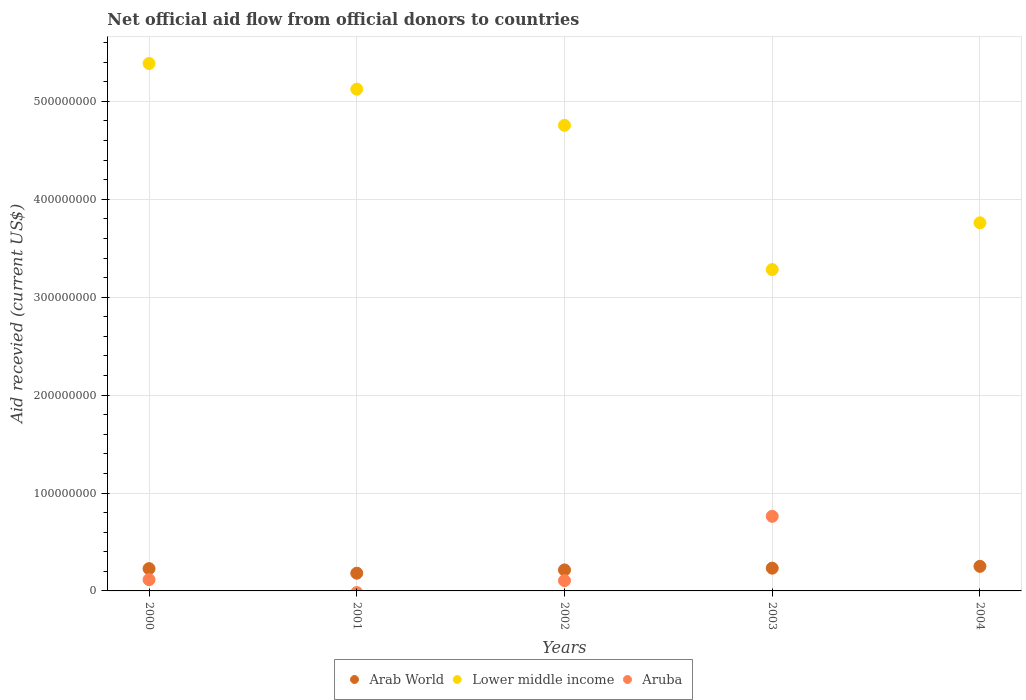How many different coloured dotlines are there?
Keep it short and to the point. 3. Is the number of dotlines equal to the number of legend labels?
Your response must be concise. No. What is the total aid received in Aruba in 2000?
Your answer should be compact. 1.15e+07. Across all years, what is the maximum total aid received in Aruba?
Provide a short and direct response. 7.62e+07. Across all years, what is the minimum total aid received in Lower middle income?
Keep it short and to the point. 3.28e+08. In which year was the total aid received in Lower middle income maximum?
Your response must be concise. 2000. What is the total total aid received in Arab World in the graph?
Offer a very short reply. 1.11e+08. What is the difference between the total aid received in Lower middle income in 2000 and that in 2003?
Ensure brevity in your answer.  2.10e+08. What is the difference between the total aid received in Arab World in 2002 and the total aid received in Aruba in 2000?
Your answer should be very brief. 9.94e+06. What is the average total aid received in Arab World per year?
Make the answer very short. 2.21e+07. In the year 2001, what is the difference between the total aid received in Arab World and total aid received in Lower middle income?
Make the answer very short. -4.94e+08. In how many years, is the total aid received in Lower middle income greater than 40000000 US$?
Your response must be concise. 5. What is the ratio of the total aid received in Lower middle income in 2000 to that in 2004?
Make the answer very short. 1.43. Is the total aid received in Lower middle income in 2001 less than that in 2004?
Provide a succinct answer. No. Is the difference between the total aid received in Arab World in 2000 and 2001 greater than the difference between the total aid received in Lower middle income in 2000 and 2001?
Give a very brief answer. No. What is the difference between the highest and the second highest total aid received in Arab World?
Provide a short and direct response. 1.86e+06. In how many years, is the total aid received in Aruba greater than the average total aid received in Aruba taken over all years?
Your answer should be very brief. 1. Is the sum of the total aid received in Lower middle income in 2000 and 2004 greater than the maximum total aid received in Aruba across all years?
Your answer should be compact. Yes. Is it the case that in every year, the sum of the total aid received in Lower middle income and total aid received in Arab World  is greater than the total aid received in Aruba?
Your answer should be very brief. Yes. Is the total aid received in Aruba strictly greater than the total aid received in Lower middle income over the years?
Provide a short and direct response. No. How many dotlines are there?
Keep it short and to the point. 3. What is the difference between two consecutive major ticks on the Y-axis?
Provide a succinct answer. 1.00e+08. Where does the legend appear in the graph?
Give a very brief answer. Bottom center. How many legend labels are there?
Ensure brevity in your answer.  3. How are the legend labels stacked?
Your answer should be compact. Horizontal. What is the title of the graph?
Make the answer very short. Net official aid flow from official donors to countries. Does "Brunei Darussalam" appear as one of the legend labels in the graph?
Make the answer very short. No. What is the label or title of the X-axis?
Give a very brief answer. Years. What is the label or title of the Y-axis?
Your answer should be very brief. Aid recevied (current US$). What is the Aid recevied (current US$) in Arab World in 2000?
Your answer should be compact. 2.28e+07. What is the Aid recevied (current US$) of Lower middle income in 2000?
Your answer should be compact. 5.39e+08. What is the Aid recevied (current US$) of Aruba in 2000?
Your response must be concise. 1.15e+07. What is the Aid recevied (current US$) in Arab World in 2001?
Offer a very short reply. 1.81e+07. What is the Aid recevied (current US$) of Lower middle income in 2001?
Keep it short and to the point. 5.12e+08. What is the Aid recevied (current US$) of Arab World in 2002?
Your response must be concise. 2.14e+07. What is the Aid recevied (current US$) in Lower middle income in 2002?
Your answer should be compact. 4.76e+08. What is the Aid recevied (current US$) of Aruba in 2002?
Offer a terse response. 1.05e+07. What is the Aid recevied (current US$) of Arab World in 2003?
Your answer should be compact. 2.32e+07. What is the Aid recevied (current US$) of Lower middle income in 2003?
Keep it short and to the point. 3.28e+08. What is the Aid recevied (current US$) of Aruba in 2003?
Make the answer very short. 7.62e+07. What is the Aid recevied (current US$) of Arab World in 2004?
Provide a succinct answer. 2.51e+07. What is the Aid recevied (current US$) of Lower middle income in 2004?
Provide a short and direct response. 3.76e+08. Across all years, what is the maximum Aid recevied (current US$) in Arab World?
Your response must be concise. 2.51e+07. Across all years, what is the maximum Aid recevied (current US$) in Lower middle income?
Your answer should be very brief. 5.39e+08. Across all years, what is the maximum Aid recevied (current US$) in Aruba?
Ensure brevity in your answer.  7.62e+07. Across all years, what is the minimum Aid recevied (current US$) of Arab World?
Offer a very short reply. 1.81e+07. Across all years, what is the minimum Aid recevied (current US$) of Lower middle income?
Your response must be concise. 3.28e+08. Across all years, what is the minimum Aid recevied (current US$) of Aruba?
Provide a short and direct response. 0. What is the total Aid recevied (current US$) in Arab World in the graph?
Give a very brief answer. 1.11e+08. What is the total Aid recevied (current US$) of Lower middle income in the graph?
Give a very brief answer. 2.23e+09. What is the total Aid recevied (current US$) in Aruba in the graph?
Your response must be concise. 9.82e+07. What is the difference between the Aid recevied (current US$) in Arab World in 2000 and that in 2001?
Ensure brevity in your answer.  4.67e+06. What is the difference between the Aid recevied (current US$) of Lower middle income in 2000 and that in 2001?
Offer a very short reply. 2.62e+07. What is the difference between the Aid recevied (current US$) in Arab World in 2000 and that in 2002?
Ensure brevity in your answer.  1.34e+06. What is the difference between the Aid recevied (current US$) in Lower middle income in 2000 and that in 2002?
Your answer should be very brief. 6.32e+07. What is the difference between the Aid recevied (current US$) in Aruba in 2000 and that in 2002?
Ensure brevity in your answer.  1.01e+06. What is the difference between the Aid recevied (current US$) in Arab World in 2000 and that in 2003?
Provide a short and direct response. -4.70e+05. What is the difference between the Aid recevied (current US$) of Lower middle income in 2000 and that in 2003?
Keep it short and to the point. 2.10e+08. What is the difference between the Aid recevied (current US$) in Aruba in 2000 and that in 2003?
Ensure brevity in your answer.  -6.47e+07. What is the difference between the Aid recevied (current US$) in Arab World in 2000 and that in 2004?
Your response must be concise. -2.33e+06. What is the difference between the Aid recevied (current US$) in Lower middle income in 2000 and that in 2004?
Make the answer very short. 1.63e+08. What is the difference between the Aid recevied (current US$) of Arab World in 2001 and that in 2002?
Your response must be concise. -3.33e+06. What is the difference between the Aid recevied (current US$) in Lower middle income in 2001 and that in 2002?
Give a very brief answer. 3.69e+07. What is the difference between the Aid recevied (current US$) in Arab World in 2001 and that in 2003?
Give a very brief answer. -5.14e+06. What is the difference between the Aid recevied (current US$) in Lower middle income in 2001 and that in 2003?
Offer a terse response. 1.84e+08. What is the difference between the Aid recevied (current US$) in Arab World in 2001 and that in 2004?
Your answer should be very brief. -7.00e+06. What is the difference between the Aid recevied (current US$) of Lower middle income in 2001 and that in 2004?
Provide a short and direct response. 1.36e+08. What is the difference between the Aid recevied (current US$) of Arab World in 2002 and that in 2003?
Give a very brief answer. -1.81e+06. What is the difference between the Aid recevied (current US$) of Lower middle income in 2002 and that in 2003?
Make the answer very short. 1.47e+08. What is the difference between the Aid recevied (current US$) in Aruba in 2002 and that in 2003?
Make the answer very short. -6.57e+07. What is the difference between the Aid recevied (current US$) of Arab World in 2002 and that in 2004?
Provide a succinct answer. -3.67e+06. What is the difference between the Aid recevied (current US$) of Lower middle income in 2002 and that in 2004?
Your answer should be compact. 9.96e+07. What is the difference between the Aid recevied (current US$) of Arab World in 2003 and that in 2004?
Give a very brief answer. -1.86e+06. What is the difference between the Aid recevied (current US$) in Lower middle income in 2003 and that in 2004?
Offer a terse response. -4.78e+07. What is the difference between the Aid recevied (current US$) in Arab World in 2000 and the Aid recevied (current US$) in Lower middle income in 2001?
Keep it short and to the point. -4.90e+08. What is the difference between the Aid recevied (current US$) in Arab World in 2000 and the Aid recevied (current US$) in Lower middle income in 2002?
Your answer should be very brief. -4.53e+08. What is the difference between the Aid recevied (current US$) of Arab World in 2000 and the Aid recevied (current US$) of Aruba in 2002?
Provide a short and direct response. 1.23e+07. What is the difference between the Aid recevied (current US$) of Lower middle income in 2000 and the Aid recevied (current US$) of Aruba in 2002?
Provide a succinct answer. 5.28e+08. What is the difference between the Aid recevied (current US$) in Arab World in 2000 and the Aid recevied (current US$) in Lower middle income in 2003?
Your answer should be very brief. -3.05e+08. What is the difference between the Aid recevied (current US$) of Arab World in 2000 and the Aid recevied (current US$) of Aruba in 2003?
Your response must be concise. -5.34e+07. What is the difference between the Aid recevied (current US$) of Lower middle income in 2000 and the Aid recevied (current US$) of Aruba in 2003?
Ensure brevity in your answer.  4.62e+08. What is the difference between the Aid recevied (current US$) in Arab World in 2000 and the Aid recevied (current US$) in Lower middle income in 2004?
Your answer should be very brief. -3.53e+08. What is the difference between the Aid recevied (current US$) in Arab World in 2001 and the Aid recevied (current US$) in Lower middle income in 2002?
Offer a very short reply. -4.57e+08. What is the difference between the Aid recevied (current US$) of Arab World in 2001 and the Aid recevied (current US$) of Aruba in 2002?
Provide a short and direct response. 7.62e+06. What is the difference between the Aid recevied (current US$) of Lower middle income in 2001 and the Aid recevied (current US$) of Aruba in 2002?
Keep it short and to the point. 5.02e+08. What is the difference between the Aid recevied (current US$) in Arab World in 2001 and the Aid recevied (current US$) in Lower middle income in 2003?
Your response must be concise. -3.10e+08. What is the difference between the Aid recevied (current US$) in Arab World in 2001 and the Aid recevied (current US$) in Aruba in 2003?
Provide a succinct answer. -5.81e+07. What is the difference between the Aid recevied (current US$) in Lower middle income in 2001 and the Aid recevied (current US$) in Aruba in 2003?
Your answer should be very brief. 4.36e+08. What is the difference between the Aid recevied (current US$) of Arab World in 2001 and the Aid recevied (current US$) of Lower middle income in 2004?
Your response must be concise. -3.58e+08. What is the difference between the Aid recevied (current US$) in Arab World in 2002 and the Aid recevied (current US$) in Lower middle income in 2003?
Offer a very short reply. -3.07e+08. What is the difference between the Aid recevied (current US$) of Arab World in 2002 and the Aid recevied (current US$) of Aruba in 2003?
Keep it short and to the point. -5.48e+07. What is the difference between the Aid recevied (current US$) in Lower middle income in 2002 and the Aid recevied (current US$) in Aruba in 2003?
Offer a very short reply. 3.99e+08. What is the difference between the Aid recevied (current US$) in Arab World in 2002 and the Aid recevied (current US$) in Lower middle income in 2004?
Offer a terse response. -3.55e+08. What is the difference between the Aid recevied (current US$) in Arab World in 2003 and the Aid recevied (current US$) in Lower middle income in 2004?
Your answer should be very brief. -3.53e+08. What is the average Aid recevied (current US$) of Arab World per year?
Make the answer very short. 2.21e+07. What is the average Aid recevied (current US$) in Lower middle income per year?
Keep it short and to the point. 4.46e+08. What is the average Aid recevied (current US$) of Aruba per year?
Provide a short and direct response. 1.96e+07. In the year 2000, what is the difference between the Aid recevied (current US$) in Arab World and Aid recevied (current US$) in Lower middle income?
Your answer should be very brief. -5.16e+08. In the year 2000, what is the difference between the Aid recevied (current US$) in Arab World and Aid recevied (current US$) in Aruba?
Your response must be concise. 1.13e+07. In the year 2000, what is the difference between the Aid recevied (current US$) of Lower middle income and Aid recevied (current US$) of Aruba?
Provide a short and direct response. 5.27e+08. In the year 2001, what is the difference between the Aid recevied (current US$) in Arab World and Aid recevied (current US$) in Lower middle income?
Your answer should be compact. -4.94e+08. In the year 2002, what is the difference between the Aid recevied (current US$) of Arab World and Aid recevied (current US$) of Lower middle income?
Offer a terse response. -4.54e+08. In the year 2002, what is the difference between the Aid recevied (current US$) in Arab World and Aid recevied (current US$) in Aruba?
Offer a very short reply. 1.10e+07. In the year 2002, what is the difference between the Aid recevied (current US$) in Lower middle income and Aid recevied (current US$) in Aruba?
Provide a succinct answer. 4.65e+08. In the year 2003, what is the difference between the Aid recevied (current US$) in Arab World and Aid recevied (current US$) in Lower middle income?
Make the answer very short. -3.05e+08. In the year 2003, what is the difference between the Aid recevied (current US$) of Arab World and Aid recevied (current US$) of Aruba?
Your answer should be compact. -5.30e+07. In the year 2003, what is the difference between the Aid recevied (current US$) in Lower middle income and Aid recevied (current US$) in Aruba?
Ensure brevity in your answer.  2.52e+08. In the year 2004, what is the difference between the Aid recevied (current US$) in Arab World and Aid recevied (current US$) in Lower middle income?
Your answer should be very brief. -3.51e+08. What is the ratio of the Aid recevied (current US$) in Arab World in 2000 to that in 2001?
Your answer should be very brief. 1.26. What is the ratio of the Aid recevied (current US$) in Lower middle income in 2000 to that in 2001?
Your answer should be very brief. 1.05. What is the ratio of the Aid recevied (current US$) of Arab World in 2000 to that in 2002?
Offer a terse response. 1.06. What is the ratio of the Aid recevied (current US$) in Lower middle income in 2000 to that in 2002?
Provide a short and direct response. 1.13. What is the ratio of the Aid recevied (current US$) in Aruba in 2000 to that in 2002?
Keep it short and to the point. 1.1. What is the ratio of the Aid recevied (current US$) in Arab World in 2000 to that in 2003?
Offer a very short reply. 0.98. What is the ratio of the Aid recevied (current US$) of Lower middle income in 2000 to that in 2003?
Provide a succinct answer. 1.64. What is the ratio of the Aid recevied (current US$) in Aruba in 2000 to that in 2003?
Provide a succinct answer. 0.15. What is the ratio of the Aid recevied (current US$) of Arab World in 2000 to that in 2004?
Keep it short and to the point. 0.91. What is the ratio of the Aid recevied (current US$) in Lower middle income in 2000 to that in 2004?
Your answer should be very brief. 1.43. What is the ratio of the Aid recevied (current US$) in Arab World in 2001 to that in 2002?
Your answer should be very brief. 0.84. What is the ratio of the Aid recevied (current US$) in Lower middle income in 2001 to that in 2002?
Provide a short and direct response. 1.08. What is the ratio of the Aid recevied (current US$) of Arab World in 2001 to that in 2003?
Your response must be concise. 0.78. What is the ratio of the Aid recevied (current US$) of Lower middle income in 2001 to that in 2003?
Offer a terse response. 1.56. What is the ratio of the Aid recevied (current US$) in Arab World in 2001 to that in 2004?
Your answer should be very brief. 0.72. What is the ratio of the Aid recevied (current US$) of Lower middle income in 2001 to that in 2004?
Ensure brevity in your answer.  1.36. What is the ratio of the Aid recevied (current US$) in Arab World in 2002 to that in 2003?
Your response must be concise. 0.92. What is the ratio of the Aid recevied (current US$) in Lower middle income in 2002 to that in 2003?
Your answer should be very brief. 1.45. What is the ratio of the Aid recevied (current US$) of Aruba in 2002 to that in 2003?
Your answer should be very brief. 0.14. What is the ratio of the Aid recevied (current US$) in Arab World in 2002 to that in 2004?
Offer a terse response. 0.85. What is the ratio of the Aid recevied (current US$) in Lower middle income in 2002 to that in 2004?
Offer a very short reply. 1.26. What is the ratio of the Aid recevied (current US$) of Arab World in 2003 to that in 2004?
Keep it short and to the point. 0.93. What is the ratio of the Aid recevied (current US$) in Lower middle income in 2003 to that in 2004?
Make the answer very short. 0.87. What is the difference between the highest and the second highest Aid recevied (current US$) of Arab World?
Provide a succinct answer. 1.86e+06. What is the difference between the highest and the second highest Aid recevied (current US$) in Lower middle income?
Give a very brief answer. 2.62e+07. What is the difference between the highest and the second highest Aid recevied (current US$) in Aruba?
Your answer should be very brief. 6.47e+07. What is the difference between the highest and the lowest Aid recevied (current US$) in Lower middle income?
Keep it short and to the point. 2.10e+08. What is the difference between the highest and the lowest Aid recevied (current US$) of Aruba?
Provide a short and direct response. 7.62e+07. 